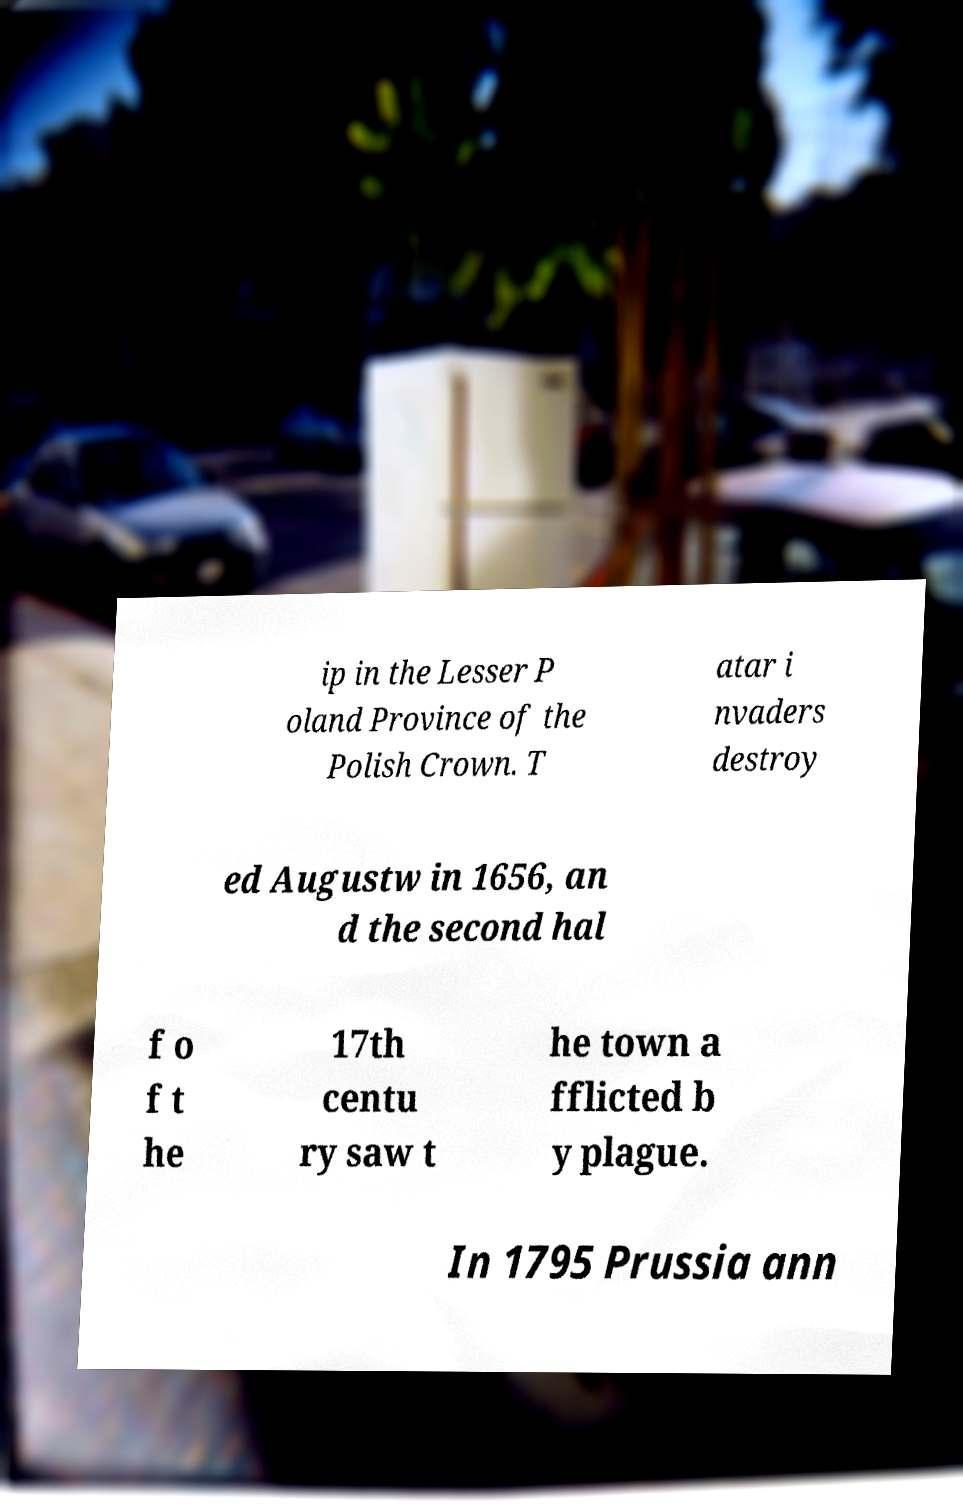Could you extract and type out the text from this image? ip in the Lesser P oland Province of the Polish Crown. T atar i nvaders destroy ed Augustw in 1656, an d the second hal f o f t he 17th centu ry saw t he town a fflicted b y plague. In 1795 Prussia ann 